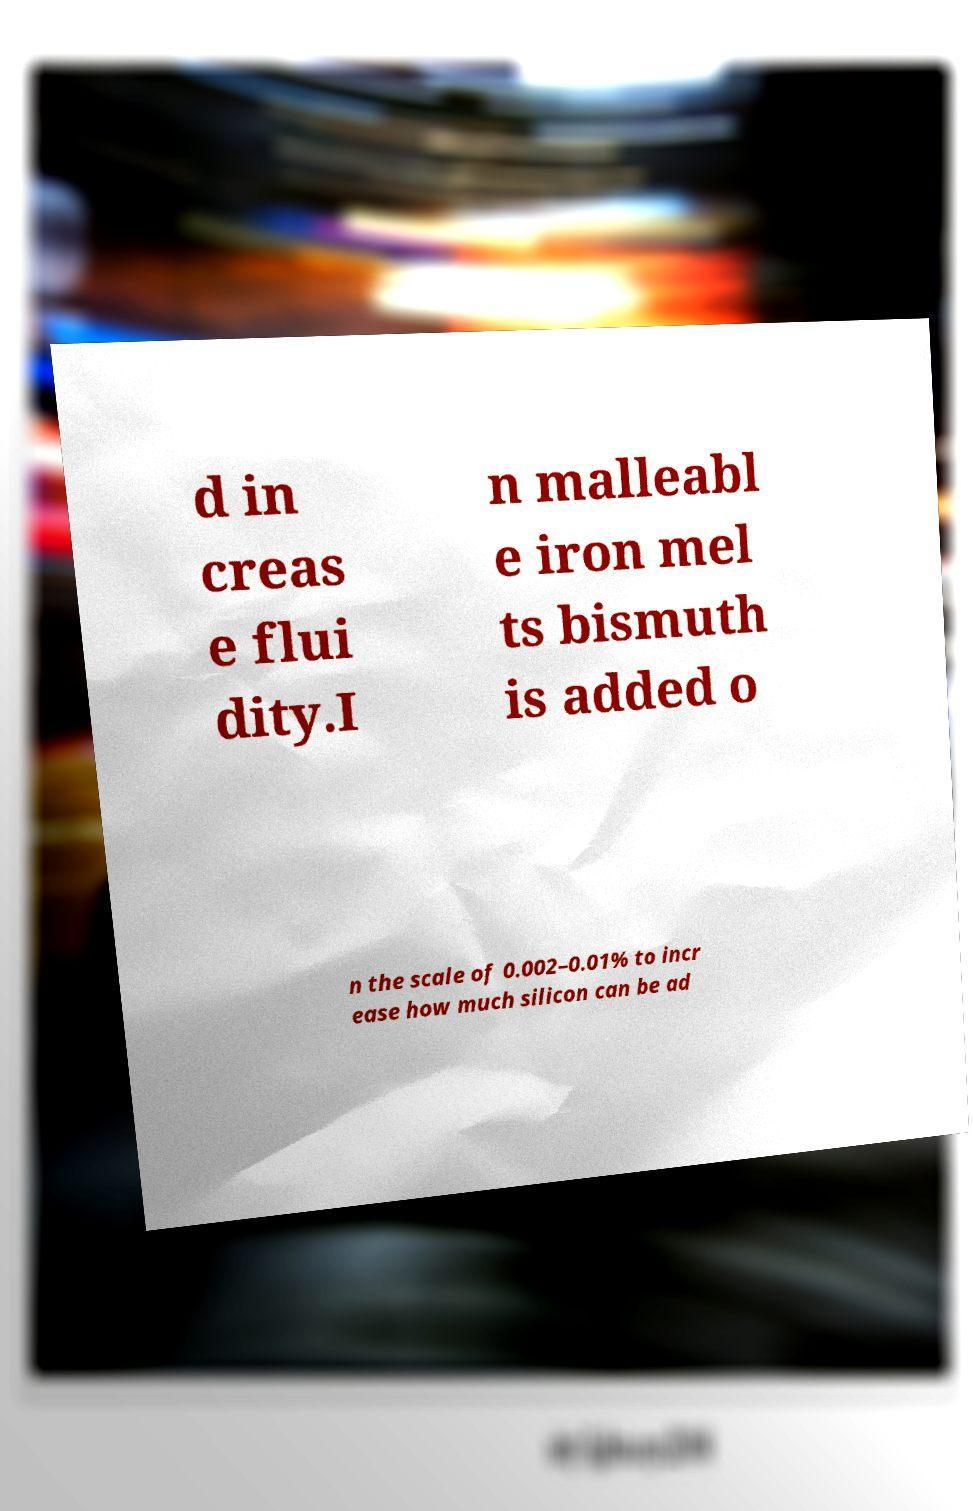Could you assist in decoding the text presented in this image and type it out clearly? d in creas e flui dity.I n malleabl e iron mel ts bismuth is added o n the scale of 0.002–0.01% to incr ease how much silicon can be ad 